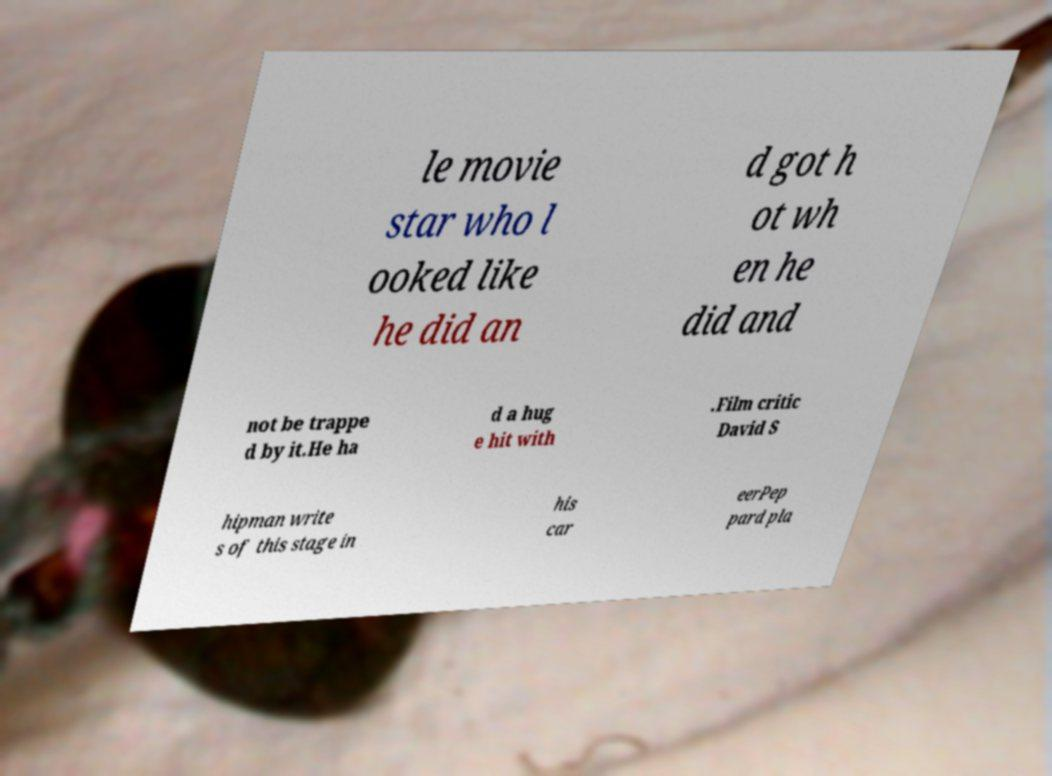For documentation purposes, I need the text within this image transcribed. Could you provide that? le movie star who l ooked like he did an d got h ot wh en he did and not be trappe d by it.He ha d a hug e hit with .Film critic David S hipman write s of this stage in his car eerPep pard pla 